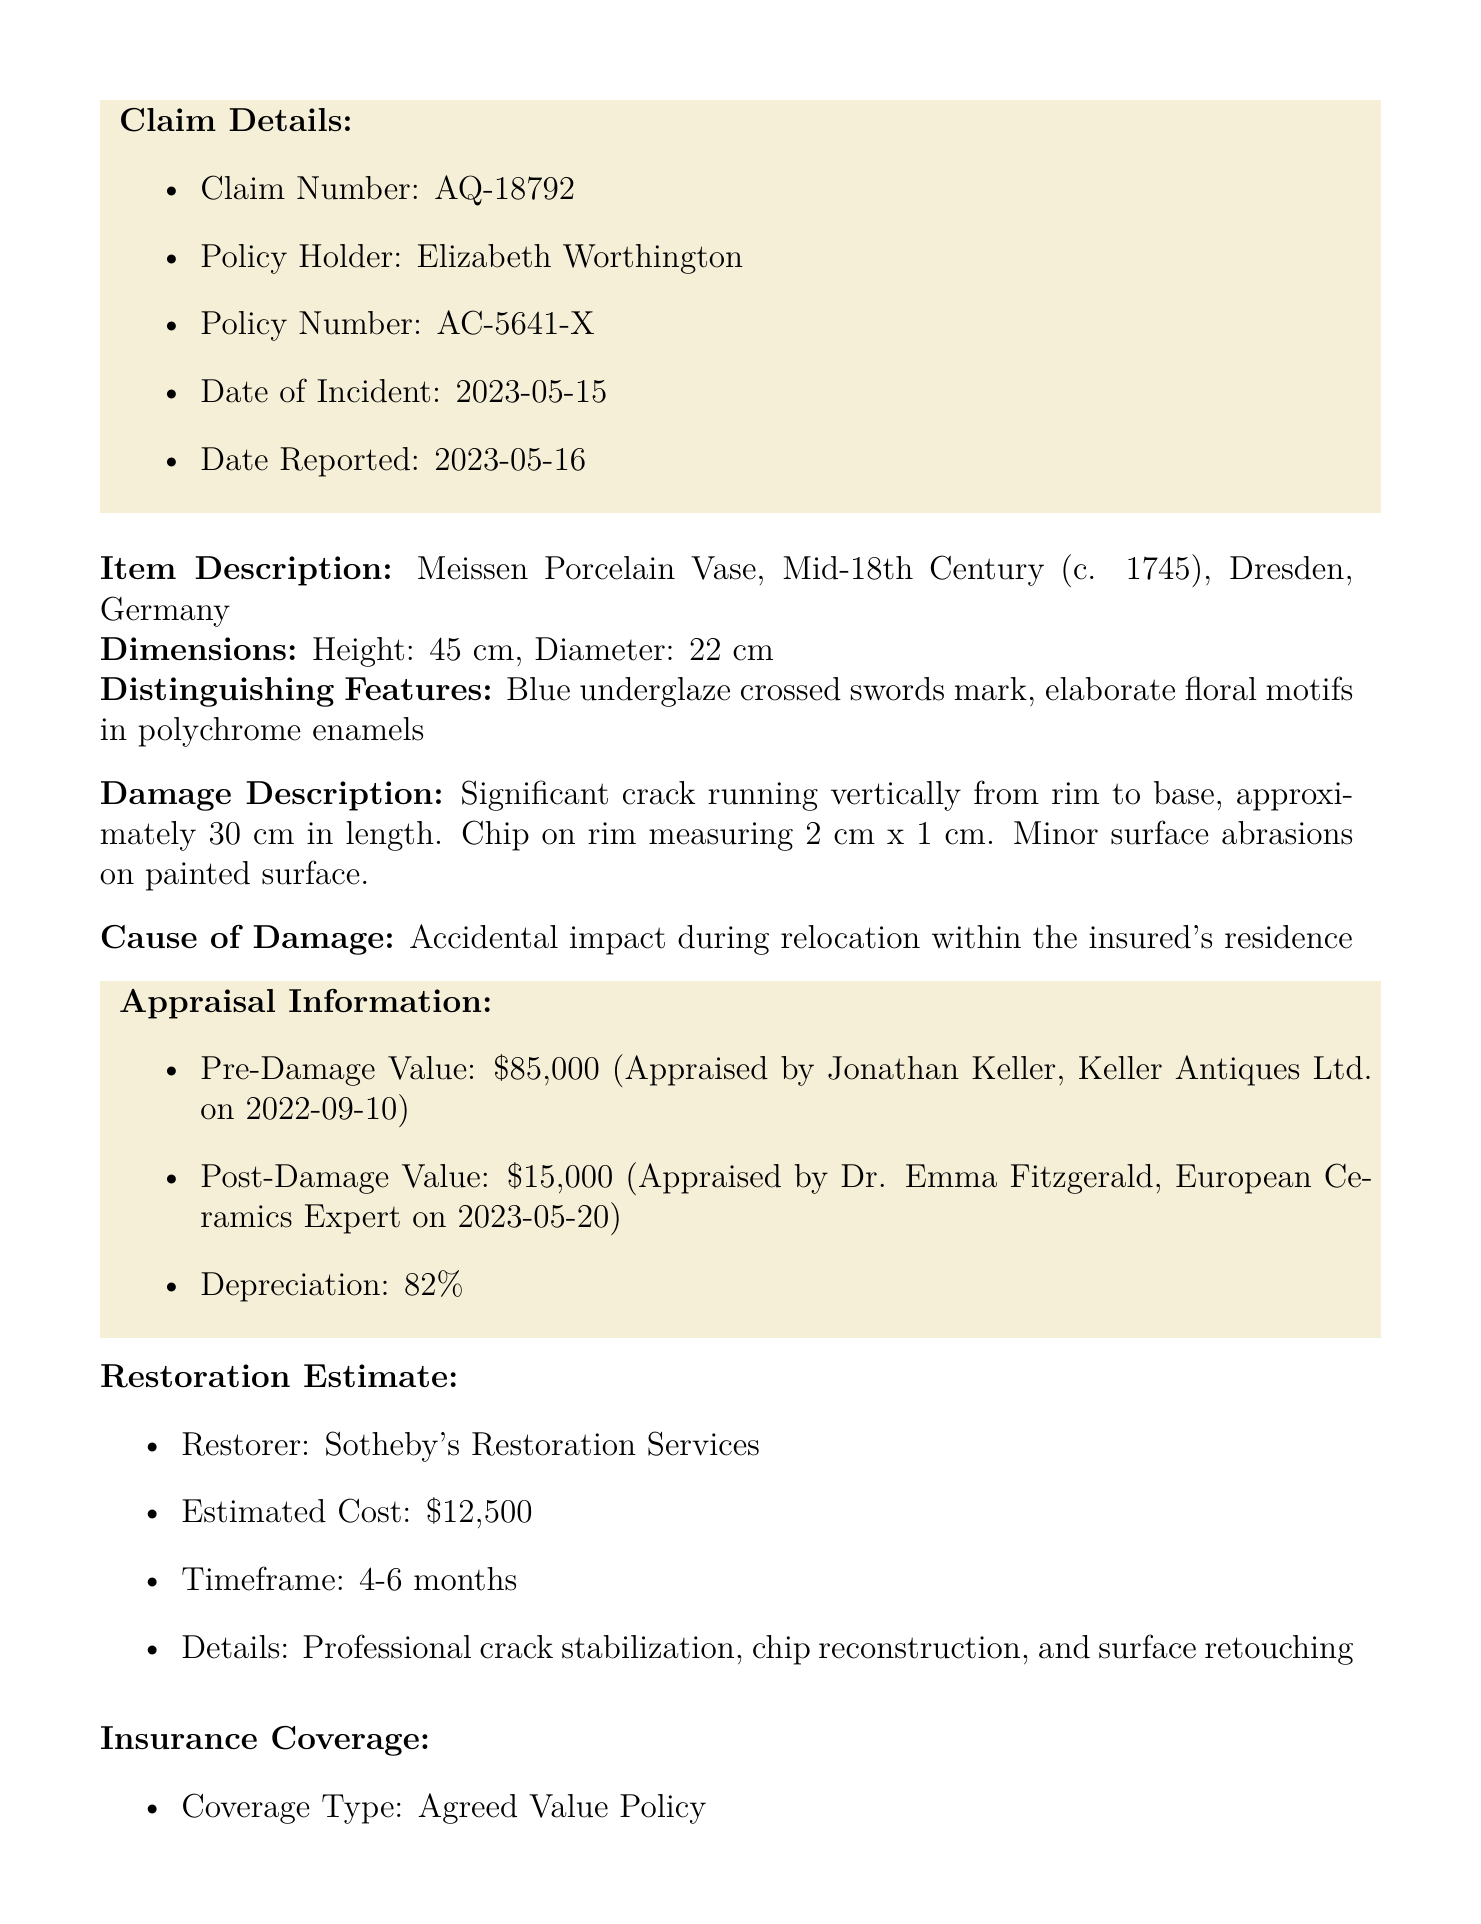What is the claim number? The claim number is listed in the claim details section of the document.
Answer: AQ-18792 Who is the policy holder? The policy holder's name is mentioned in the claim details of the document.
Answer: Elizabeth Worthington What is the date of the incident? The date of the incident is specified in the claim details section of the document.
Answer: 2023-05-15 What is the pre-damage appraisal value? The pre-damage appraisal value can be found in the appraisal information section of the document.
Answer: $85,000 What is the estimated cost for restoration? The estimated cost for restoration is provided in the restoration estimate section of the document.
Answer: $12,500 What is the depreciation percentage? The depreciation percentage is outlined in the appraisal information section of the document.
Answer: 82% What is the coverage limit of the insurance policy? The coverage limit is indicated in the insurance coverage section of the document.
Answer: $90,000 What is the recommended action following the incident? The recommended action is summarized at the end of the document.
Answer: Proceed with restoration to mitigate loss and preserve item value What is the timeframe for restoration? The timeframe for restoration is included in the restoration estimate section of the document.
Answer: 4-6 months What type of policy is this insurance coverage? The type of policy is specified in the insurance coverage section of the document.
Answer: Agreed Value Policy 